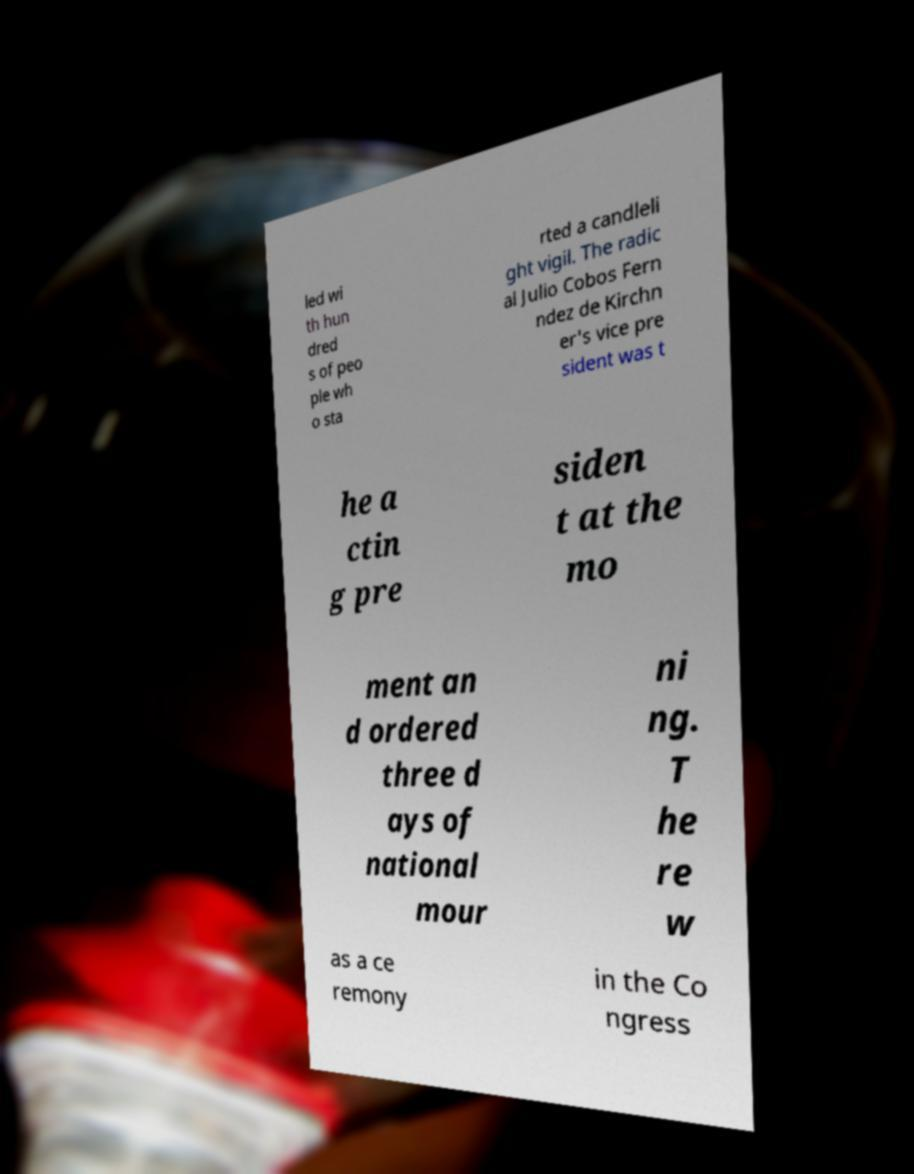Could you extract and type out the text from this image? led wi th hun dred s of peo ple wh o sta rted a candleli ght vigil. The radic al Julio Cobos Fern ndez de Kirchn er's vice pre sident was t he a ctin g pre siden t at the mo ment an d ordered three d ays of national mour ni ng. T he re w as a ce remony in the Co ngress 